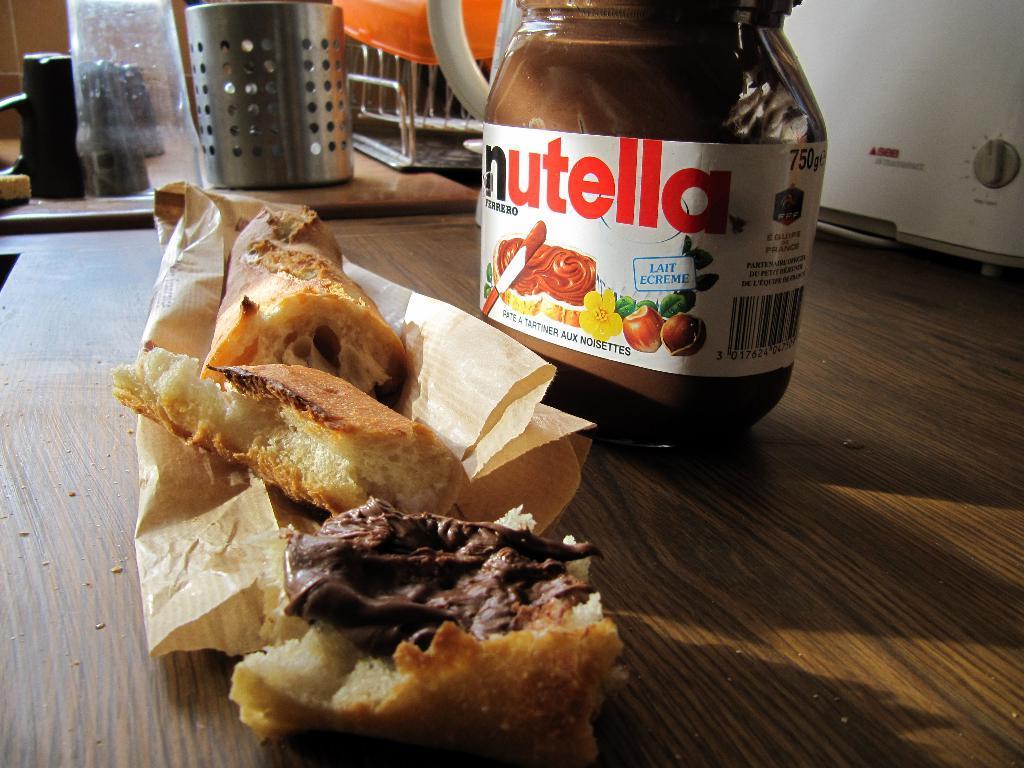Can you describe this image briefly? In this image there is a wooden table , on the table there is a glass bottle, bread pieces, paper, in the top left there is a steel container, basket, glasses kept on the table, in the top right there is a machine. 